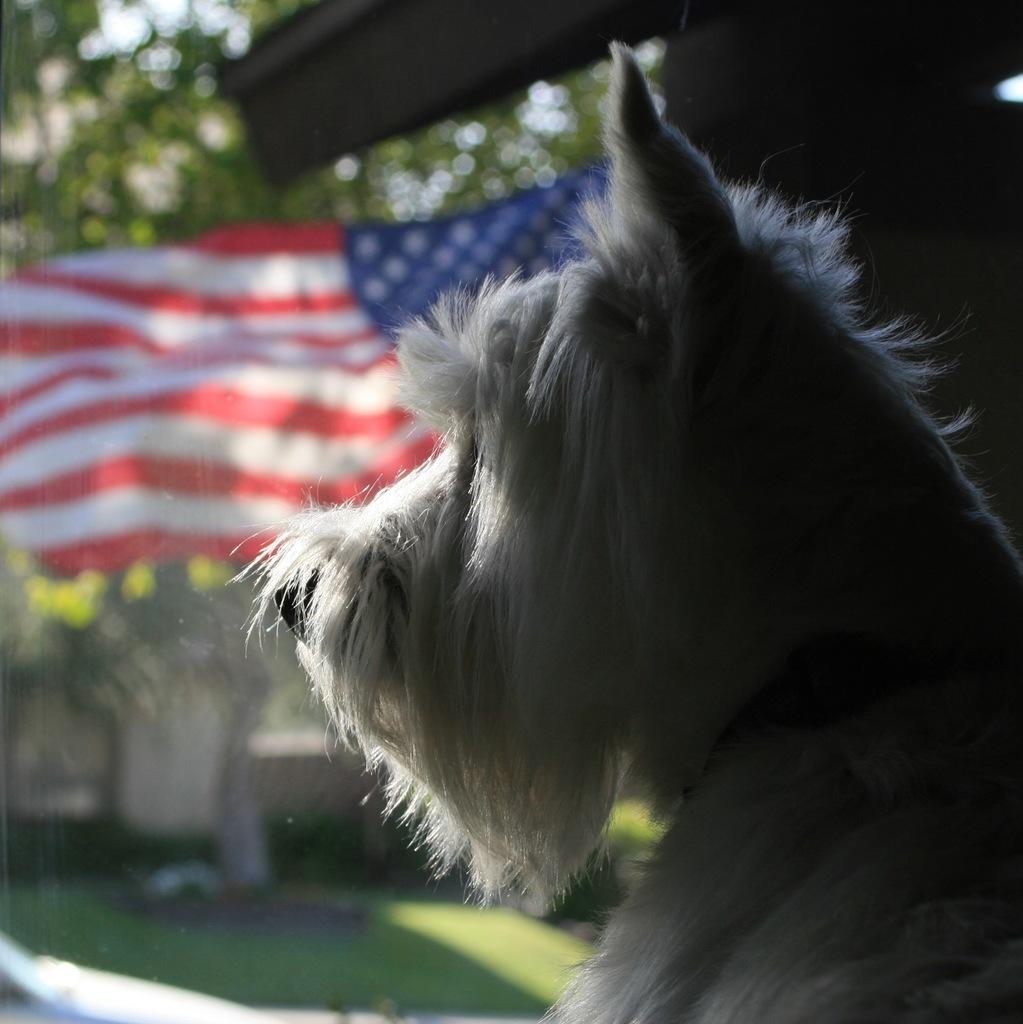What type of animal can be seen in the picture? There is a dog in the picture. What other object is present in the image? There is a flag in the picture. Can you describe the background of the image? The background of the image is blurred. What color bead is hanging from the dog's collar in the image? There is no bead present in the image, and the dog's collar is not visible. 